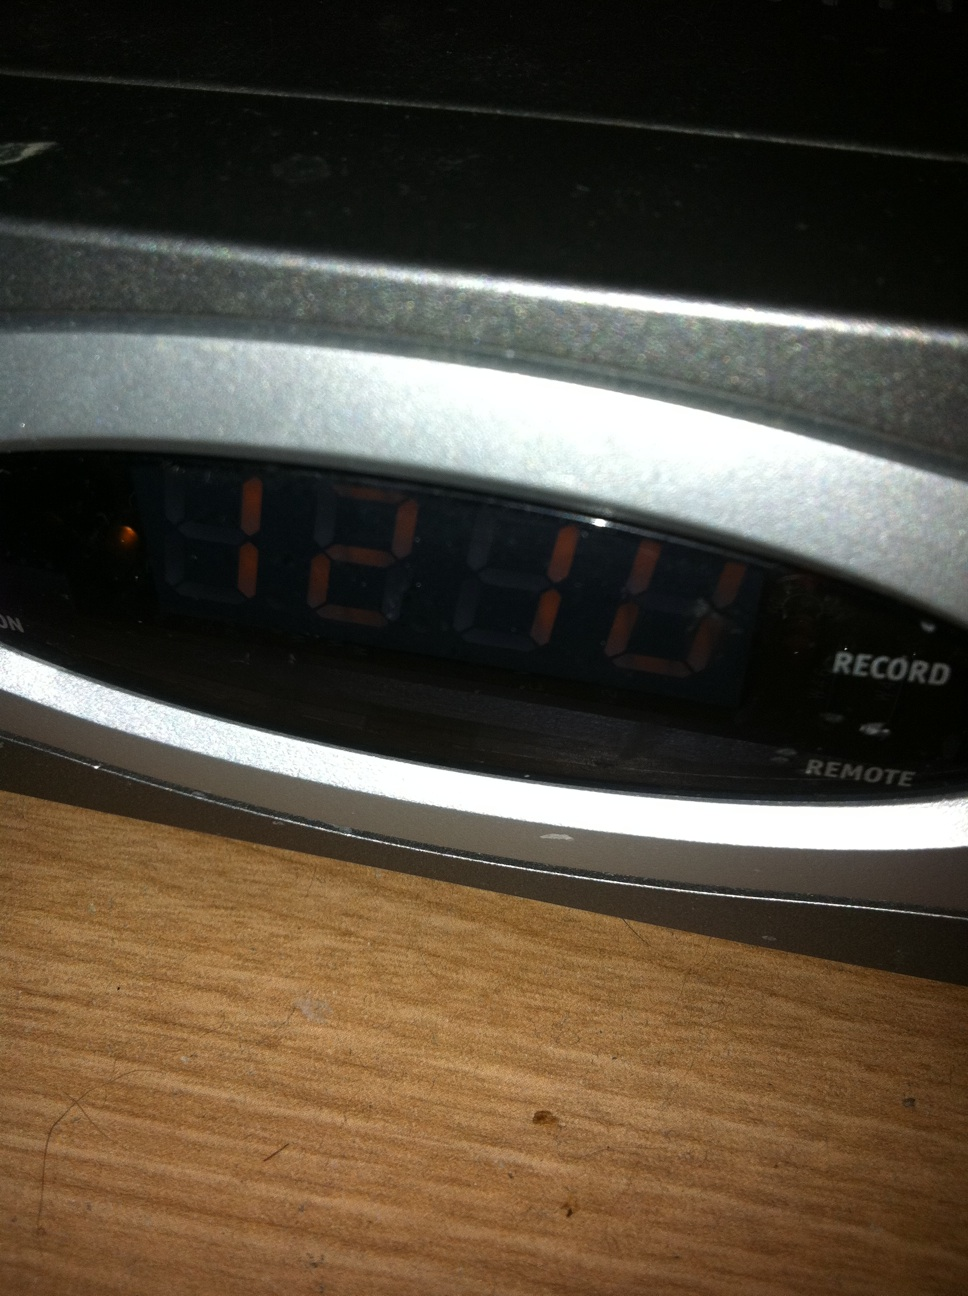What time does it say, on my set top box? Thank you. The time displayed on your set-top box is 12:10. This likely indicates it is either 12:10 AM or PM. If you have just turned on the device, it might also be the default time setting. 